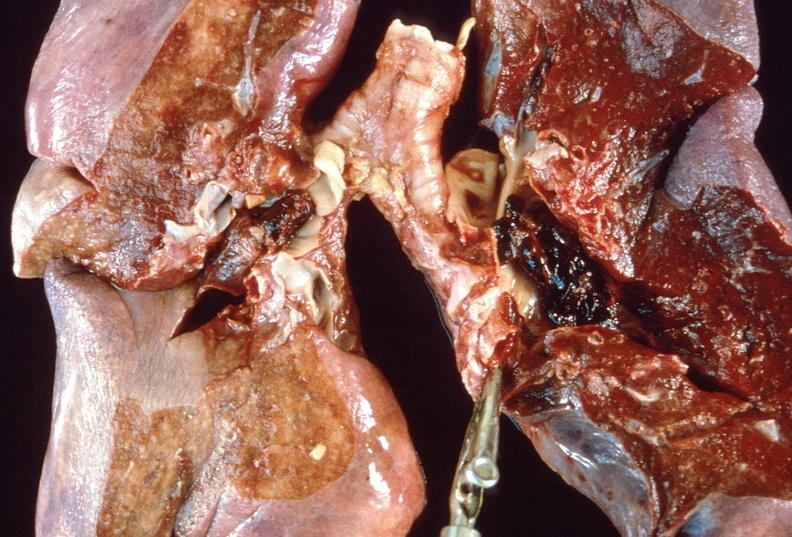does this image show pulmonary thromboemboli?
Answer the question using a single word or phrase. Yes 